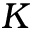Convert formula to latex. <formula><loc_0><loc_0><loc_500><loc_500>K</formula> 